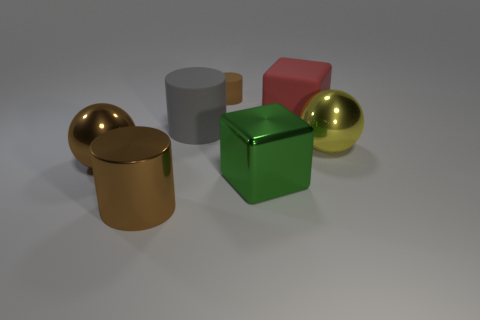Add 2 large blocks. How many objects exist? 9 Subtract all rubber cylinders. How many cylinders are left? 1 Subtract all green cubes. How many cubes are left? 1 Add 7 big blocks. How many big blocks are left? 9 Add 4 big metallic balls. How many big metallic balls exist? 6 Subtract 0 cyan cylinders. How many objects are left? 7 Subtract all cylinders. How many objects are left? 4 Subtract all brown spheres. Subtract all cyan cylinders. How many spheres are left? 1 Subtract all red blocks. How many gray cylinders are left? 1 Subtract all brown cylinders. Subtract all green metallic cubes. How many objects are left? 4 